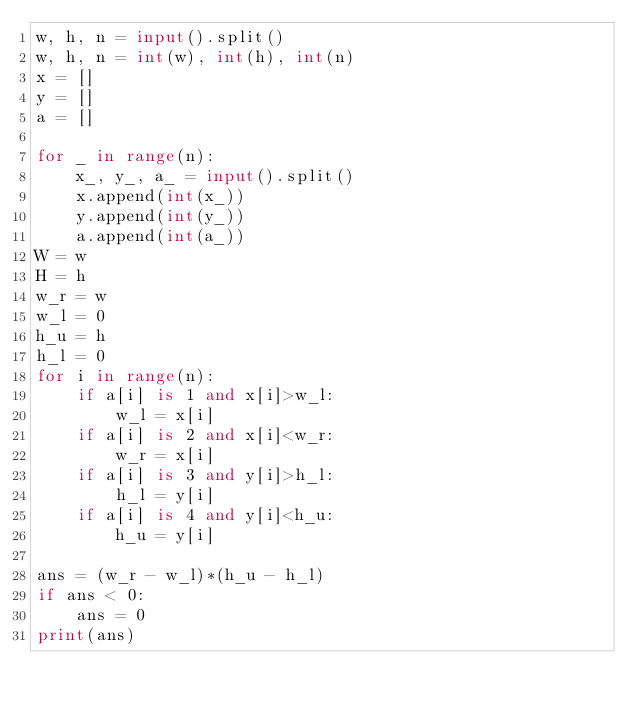<code> <loc_0><loc_0><loc_500><loc_500><_Python_>w, h, n = input().split()        
w, h, n = int(w), int(h), int(n) 
x = []                           
y = []                           
a = []                           
                                 
for _ in range(n):               
    x_, y_, a_ = input().split() 
    x.append(int(x_))            
    y.append(int(y_))            
    a.append(int(a_))            
W = w                            
H = h                            
w_r = w                          
w_l = 0                          
h_u = h                          
h_l = 0                          
for i in range(n):               
    if a[i] is 1 and x[i]>w_l:   
        w_l = x[i]               
    if a[i] is 2 and x[i]<w_r:   
        w_r = x[i]               
    if a[i] is 3 and y[i]>h_l:   
        h_l = y[i]               
    if a[i] is 4 and y[i]<h_u:   
        h_u = y[i]               
                                 
ans = (w_r - w_l)*(h_u - h_l)    
if ans < 0:                      
    ans = 0                      
print(ans)                       
</code> 